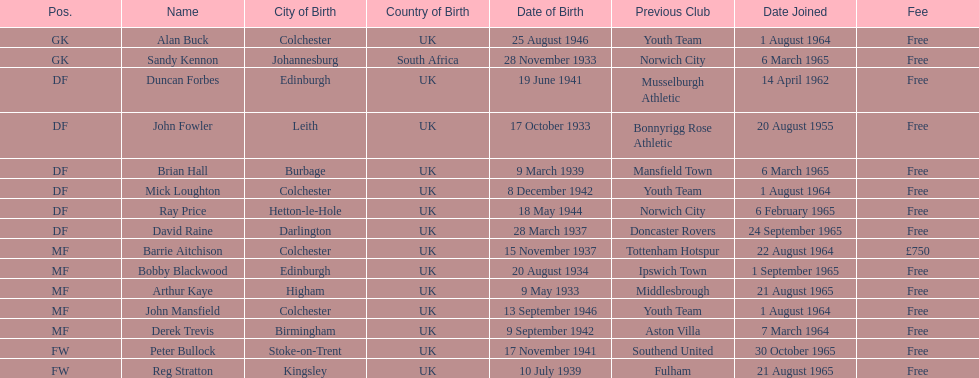What is the other fee listed, besides free? £750. 